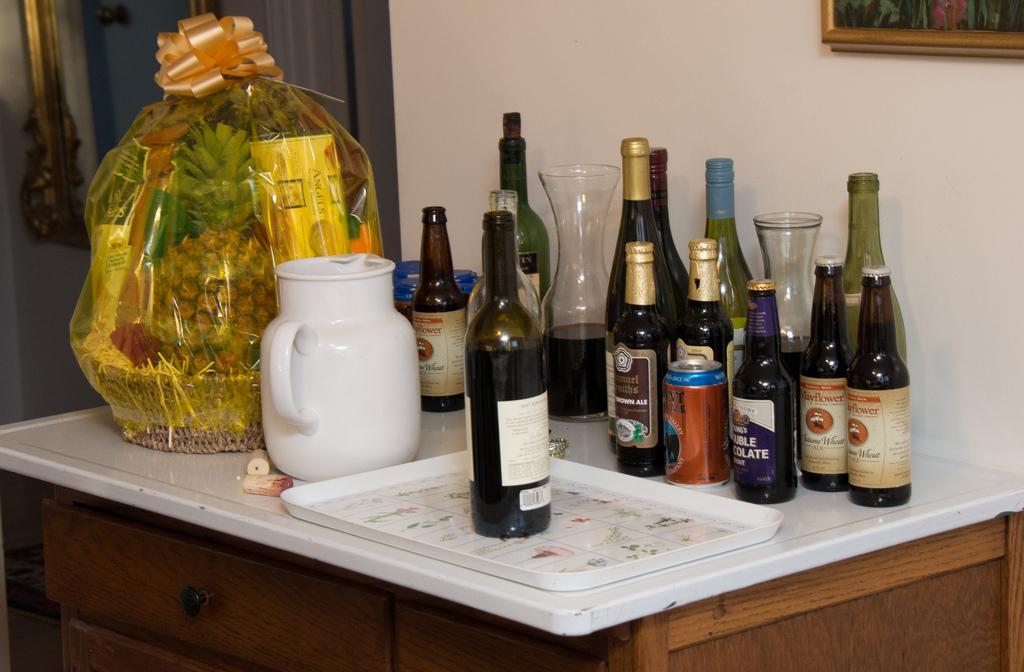Please provide a concise description of this image. In this image there is a table in the center. On the table there are group of bottles, a can, a tray, a jar and a basket. In the background there is a wall. Towards the right top there is a photo frame. 